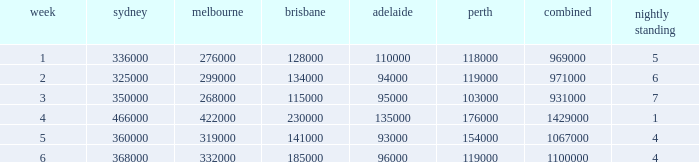What was the rating in Brisbane the week it was 276000 in Melbourne?  128000.0. Help me parse the entirety of this table. {'header': ['week', 'sydney', 'melbourne', 'brisbane', 'adelaide', 'perth', 'combined', 'nightly standing'], 'rows': [['1', '336000', '276000', '128000', '110000', '118000', '969000', '5'], ['2', '325000', '299000', '134000', '94000', '119000', '971000', '6'], ['3', '350000', '268000', '115000', '95000', '103000', '931000', '7'], ['4', '466000', '422000', '230000', '135000', '176000', '1429000', '1'], ['5', '360000', '319000', '141000', '93000', '154000', '1067000', '4'], ['6', '368000', '332000', '185000', '96000', '119000', '1100000', '4']]} 